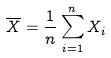Convert formula to latex. <formula><loc_0><loc_0><loc_500><loc_500>\overline { X } = \frac { 1 } { n } \sum _ { i = 1 } ^ { n } X _ { i }</formula> 